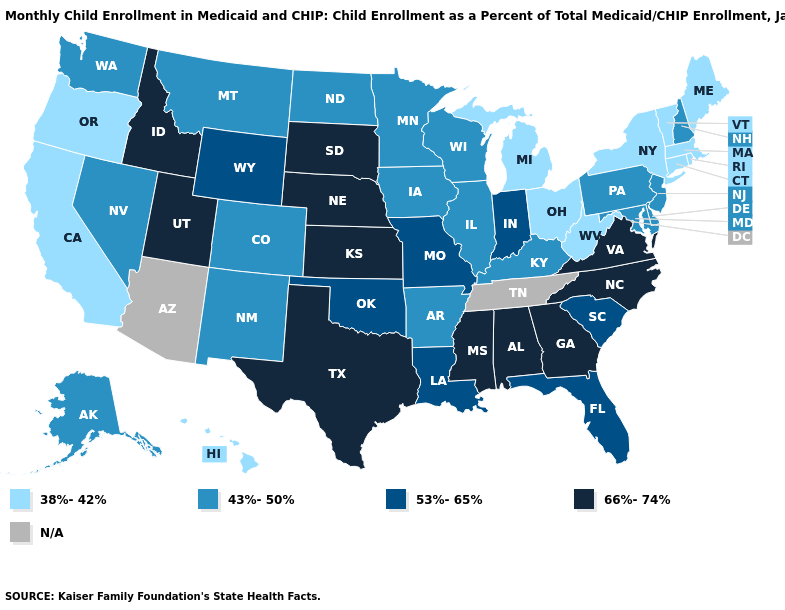Does the first symbol in the legend represent the smallest category?
Write a very short answer. Yes. What is the value of North Dakota?
Quick response, please. 43%-50%. What is the value of California?
Write a very short answer. 38%-42%. Name the states that have a value in the range 53%-65%?
Be succinct. Florida, Indiana, Louisiana, Missouri, Oklahoma, South Carolina, Wyoming. Among the states that border Vermont , does New Hampshire have the lowest value?
Write a very short answer. No. Does Maine have the lowest value in the Northeast?
Be succinct. Yes. Among the states that border Kentucky , which have the lowest value?
Write a very short answer. Ohio, West Virginia. What is the value of Mississippi?
Write a very short answer. 66%-74%. Among the states that border Oklahoma , does Missouri have the lowest value?
Give a very brief answer. No. Name the states that have a value in the range 38%-42%?
Concise answer only. California, Connecticut, Hawaii, Maine, Massachusetts, Michigan, New York, Ohio, Oregon, Rhode Island, Vermont, West Virginia. What is the value of Kansas?
Concise answer only. 66%-74%. Among the states that border Georgia , does South Carolina have the lowest value?
Keep it brief. Yes. What is the highest value in states that border New Jersey?
Quick response, please. 43%-50%. What is the highest value in the USA?
Keep it brief. 66%-74%. 